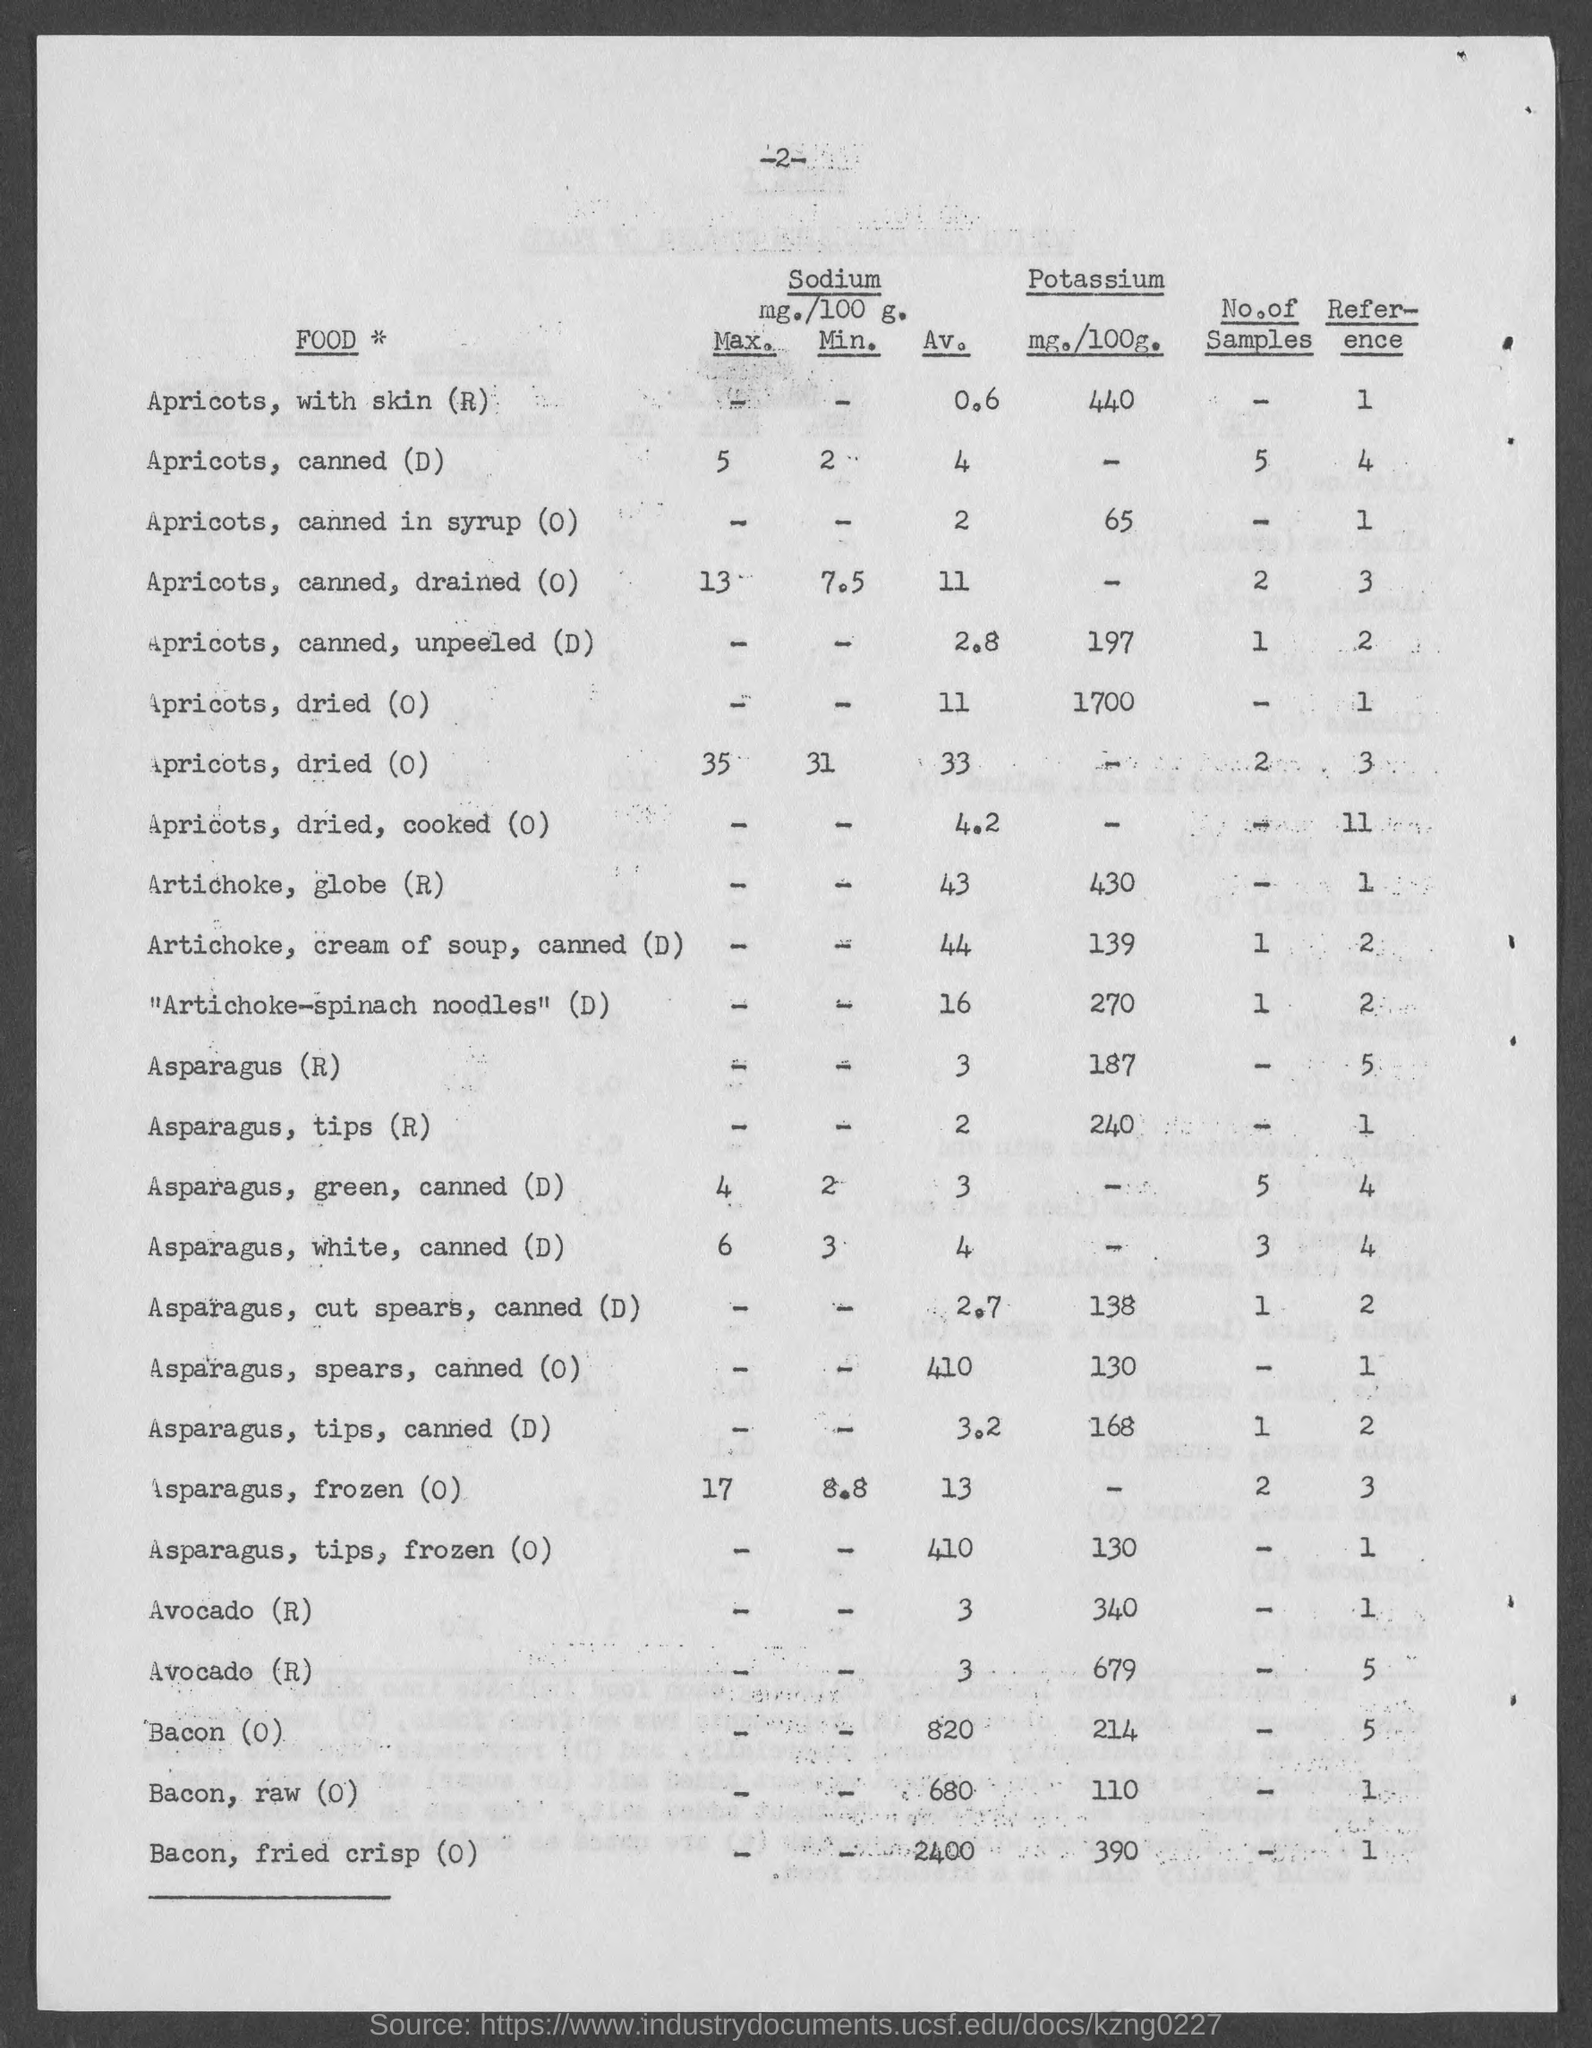What is the number at top of the page ?
Your answer should be very brief. 2. What is the amount of potassium mg./100g.  for apricots, with skin ?
Your answer should be very brief. 440. What is the amount of potassium mg./100g.  for apricots, canned in syrup?
Your answer should be very brief. 65. What is the amount of potassium mg./100g.  for apricots, canned, unpeeled ?
Provide a short and direct response. 197. What is the amount of potassium mg./100g.  for artichoke, globe ?
Your answer should be very brief. 430. What is the amount of potassium mg./100g.  for artichoke, cream of soup, canned?
Your answer should be very brief. 139. What is the amount of potassium mg./100g.  for "artichoke-spinach noodles"?
Your answer should be compact. 270. What is the amount of potassium mg./100g.  for asparagus ?
Ensure brevity in your answer.  187. What is the amount of potassium mg./100g.  for asparagus, tips ?
Your answer should be very brief. 240. What is the amount of potassium mg./100g.  for bacon?
Your response must be concise. 214. 